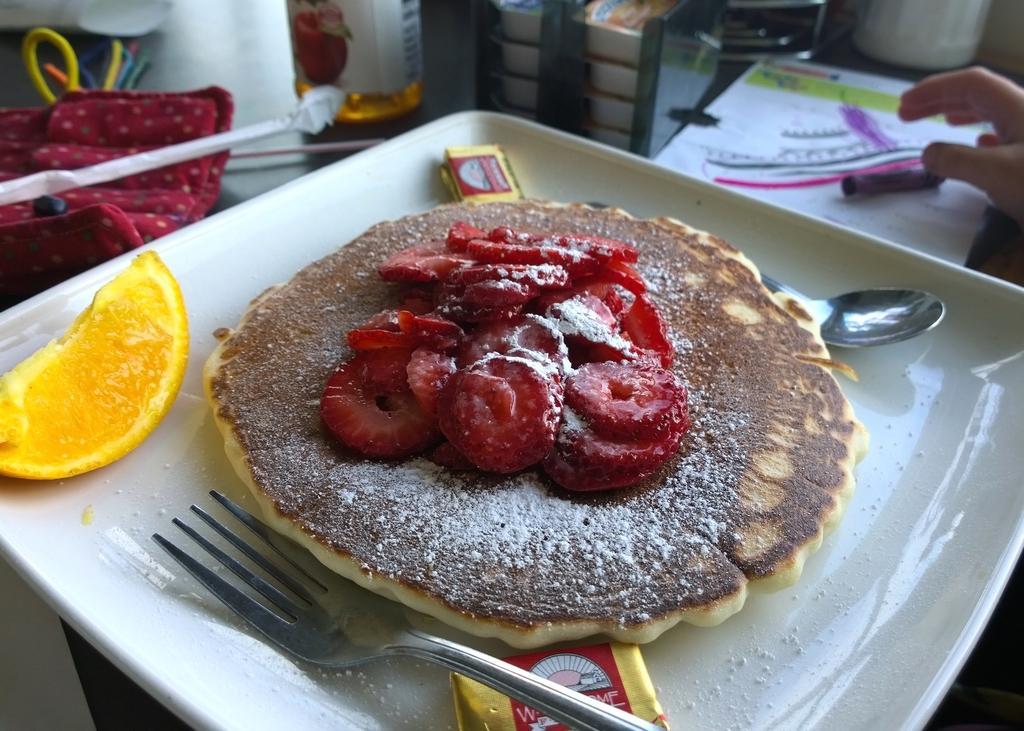Please provide a concise description of this image. At the bottom of the image there is a table, on the table there are some plates and spoons and food and fruits and cloth and bottle and paper and hand. 